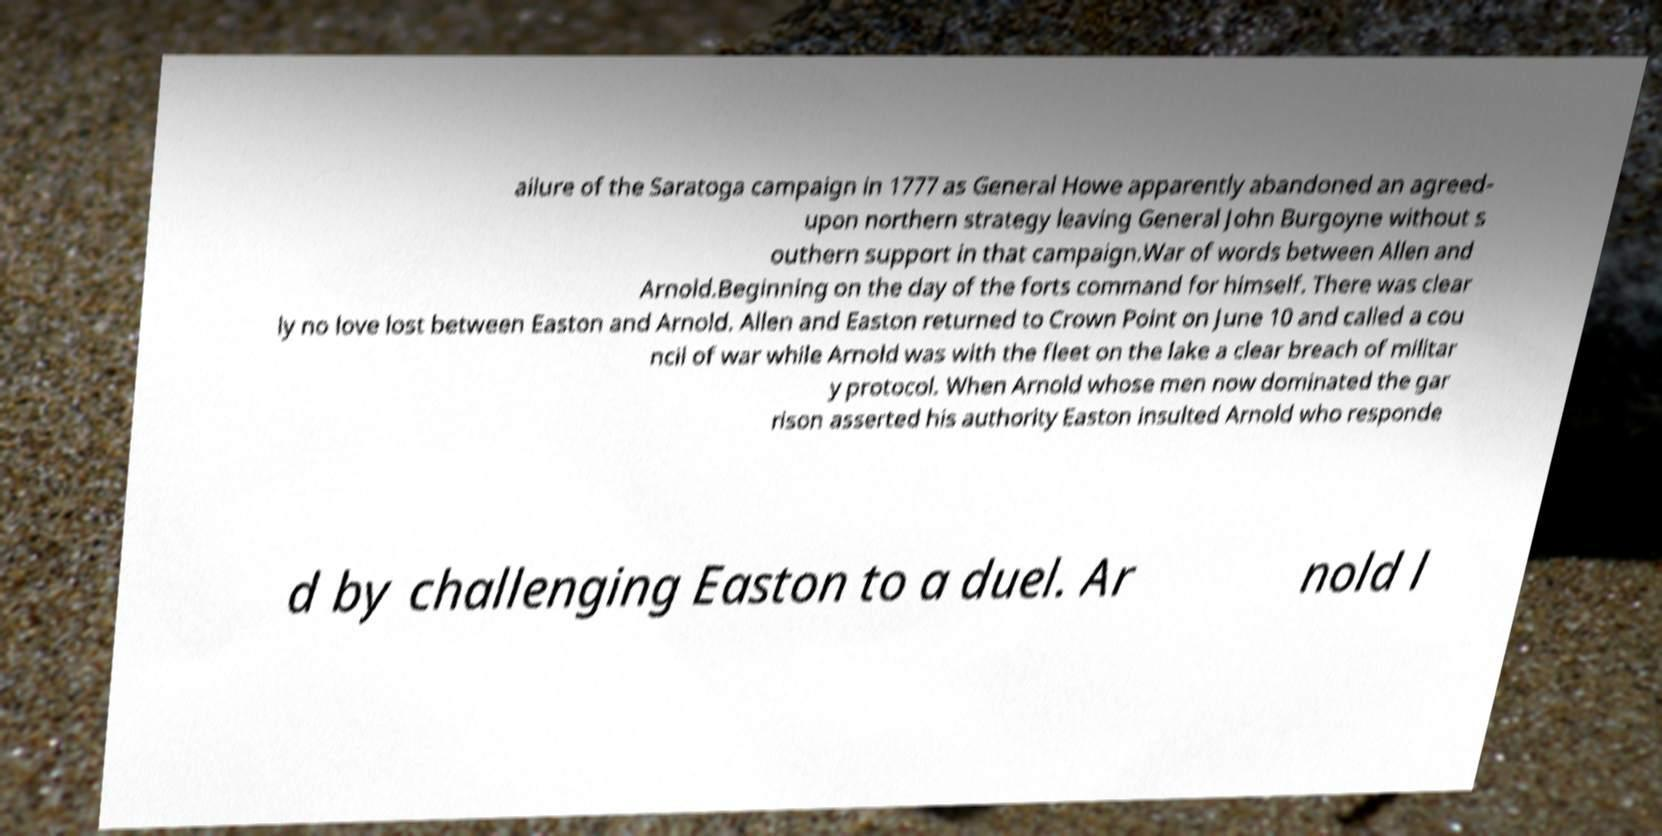Please read and relay the text visible in this image. What does it say? ailure of the Saratoga campaign in 1777 as General Howe apparently abandoned an agreed- upon northern strategy leaving General John Burgoyne without s outhern support in that campaign.War of words between Allen and Arnold.Beginning on the day of the forts command for himself. There was clear ly no love lost between Easton and Arnold. Allen and Easton returned to Crown Point on June 10 and called a cou ncil of war while Arnold was with the fleet on the lake a clear breach of militar y protocol. When Arnold whose men now dominated the gar rison asserted his authority Easton insulted Arnold who responde d by challenging Easton to a duel. Ar nold l 